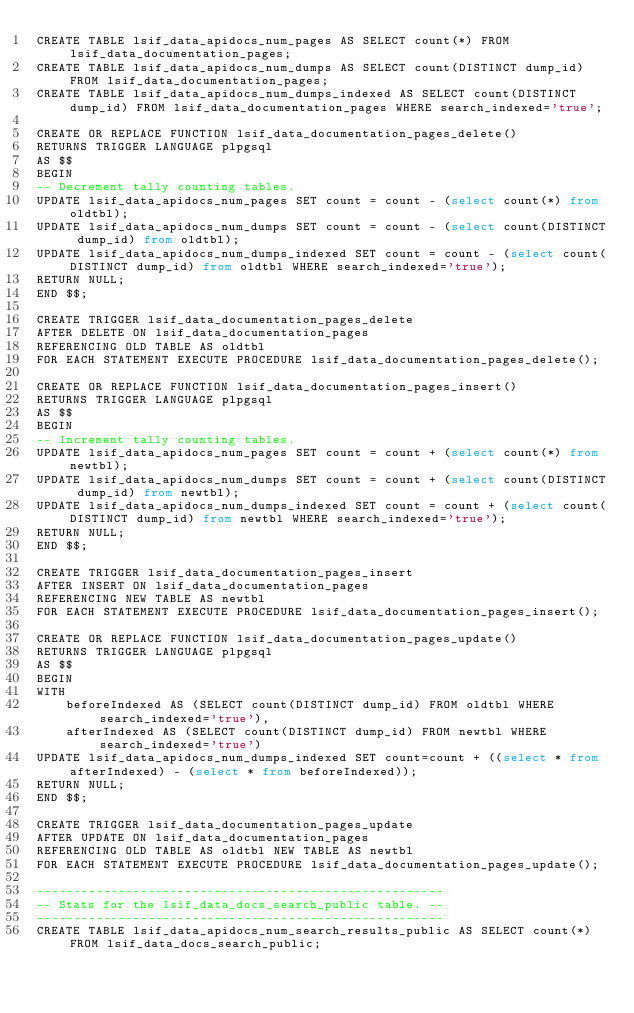<code> <loc_0><loc_0><loc_500><loc_500><_SQL_>CREATE TABLE lsif_data_apidocs_num_pages AS SELECT count(*) FROM lsif_data_documentation_pages;
CREATE TABLE lsif_data_apidocs_num_dumps AS SELECT count(DISTINCT dump_id) FROM lsif_data_documentation_pages;
CREATE TABLE lsif_data_apidocs_num_dumps_indexed AS SELECT count(DISTINCT dump_id) FROM lsif_data_documentation_pages WHERE search_indexed='true';

CREATE OR REPLACE FUNCTION lsif_data_documentation_pages_delete()
RETURNS TRIGGER LANGUAGE plpgsql
AS $$
BEGIN
-- Decrement tally counting tables.
UPDATE lsif_data_apidocs_num_pages SET count = count - (select count(*) from oldtbl);
UPDATE lsif_data_apidocs_num_dumps SET count = count - (select count(DISTINCT dump_id) from oldtbl);
UPDATE lsif_data_apidocs_num_dumps_indexed SET count = count - (select count(DISTINCT dump_id) from oldtbl WHERE search_indexed='true');
RETURN NULL;
END $$;

CREATE TRIGGER lsif_data_documentation_pages_delete
AFTER DELETE ON lsif_data_documentation_pages
REFERENCING OLD TABLE AS oldtbl
FOR EACH STATEMENT EXECUTE PROCEDURE lsif_data_documentation_pages_delete();

CREATE OR REPLACE FUNCTION lsif_data_documentation_pages_insert()
RETURNS TRIGGER LANGUAGE plpgsql
AS $$
BEGIN
-- Increment tally counting tables.
UPDATE lsif_data_apidocs_num_pages SET count = count + (select count(*) from newtbl);
UPDATE lsif_data_apidocs_num_dumps SET count = count + (select count(DISTINCT dump_id) from newtbl);
UPDATE lsif_data_apidocs_num_dumps_indexed SET count = count + (select count(DISTINCT dump_id) from newtbl WHERE search_indexed='true');
RETURN NULL;
END $$;

CREATE TRIGGER lsif_data_documentation_pages_insert
AFTER INSERT ON lsif_data_documentation_pages
REFERENCING NEW TABLE AS newtbl
FOR EACH STATEMENT EXECUTE PROCEDURE lsif_data_documentation_pages_insert();

CREATE OR REPLACE FUNCTION lsif_data_documentation_pages_update()
RETURNS TRIGGER LANGUAGE plpgsql
AS $$
BEGIN
WITH
    beforeIndexed AS (SELECT count(DISTINCT dump_id) FROM oldtbl WHERE search_indexed='true'),
    afterIndexed AS (SELECT count(DISTINCT dump_id) FROM newtbl WHERE search_indexed='true')
UPDATE lsif_data_apidocs_num_dumps_indexed SET count=count + ((select * from afterIndexed) - (select * from beforeIndexed));
RETURN NULL;
END $$;

CREATE TRIGGER lsif_data_documentation_pages_update
AFTER UPDATE ON lsif_data_documentation_pages
REFERENCING OLD TABLE AS oldtbl NEW TABLE AS newtbl
FOR EACH STATEMENT EXECUTE PROCEDURE lsif_data_documentation_pages_update();

-------------------------------------------------------
-- Stats for the lsif_data_docs_search_public table. --
-------------------------------------------------------
CREATE TABLE lsif_data_apidocs_num_search_results_public AS SELECT count(*) FROM lsif_data_docs_search_public;
</code> 